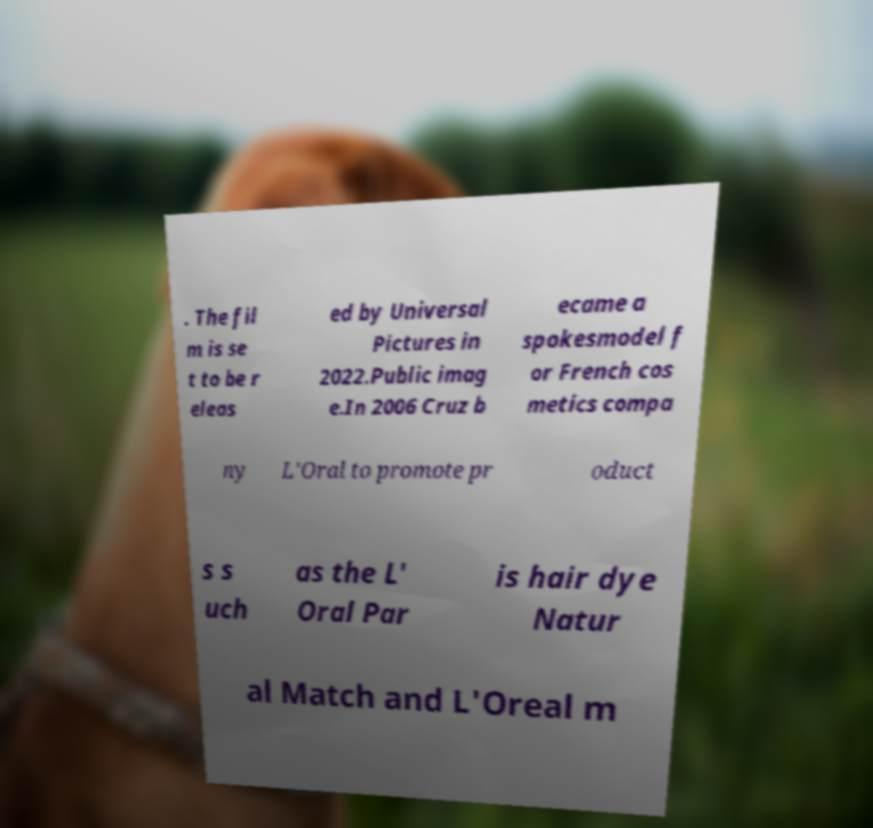Could you extract and type out the text from this image? . The fil m is se t to be r eleas ed by Universal Pictures in 2022.Public imag e.In 2006 Cruz b ecame a spokesmodel f or French cos metics compa ny L'Oral to promote pr oduct s s uch as the L' Oral Par is hair dye Natur al Match and L'Oreal m 